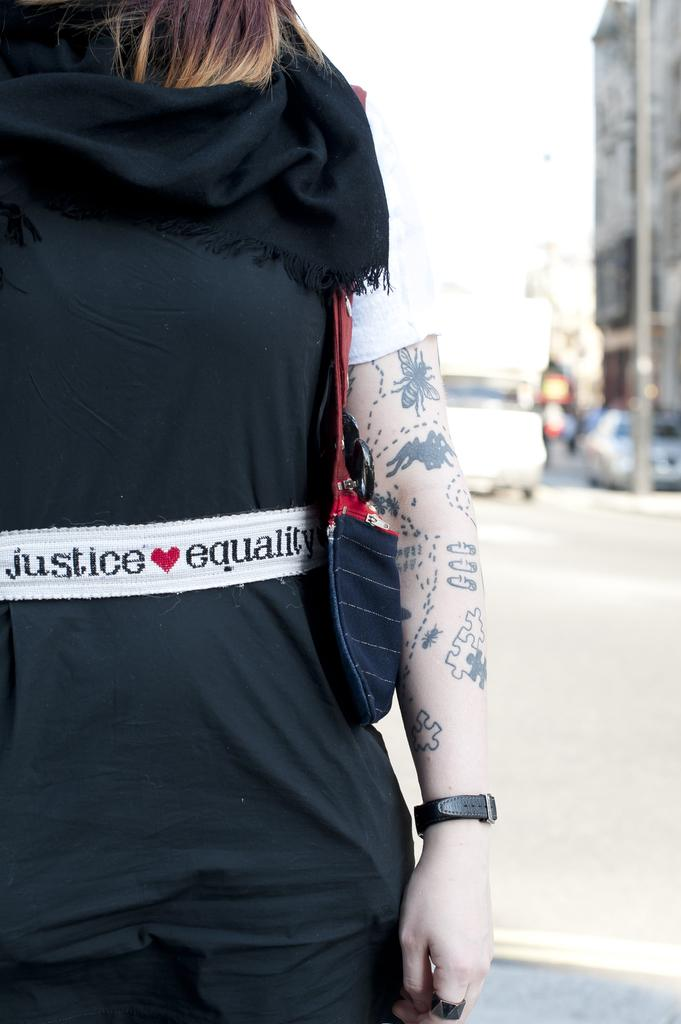What is the main subject in the foreground of the image? There is a person in the foreground of the image. Where is the person located? The person is on the road. What can be seen in the background of the image? There are vehicles, a light pole, buildings, and the sky visible in the background of the image. Can you describe the time of day when the image was taken? The image appears to be taken during the day. What language is the person speaking in the image? There is no indication of the person speaking in the image, so it cannot be determined what language they might be using. Can you see any cacti in the image? There are no cacti present in the image. 